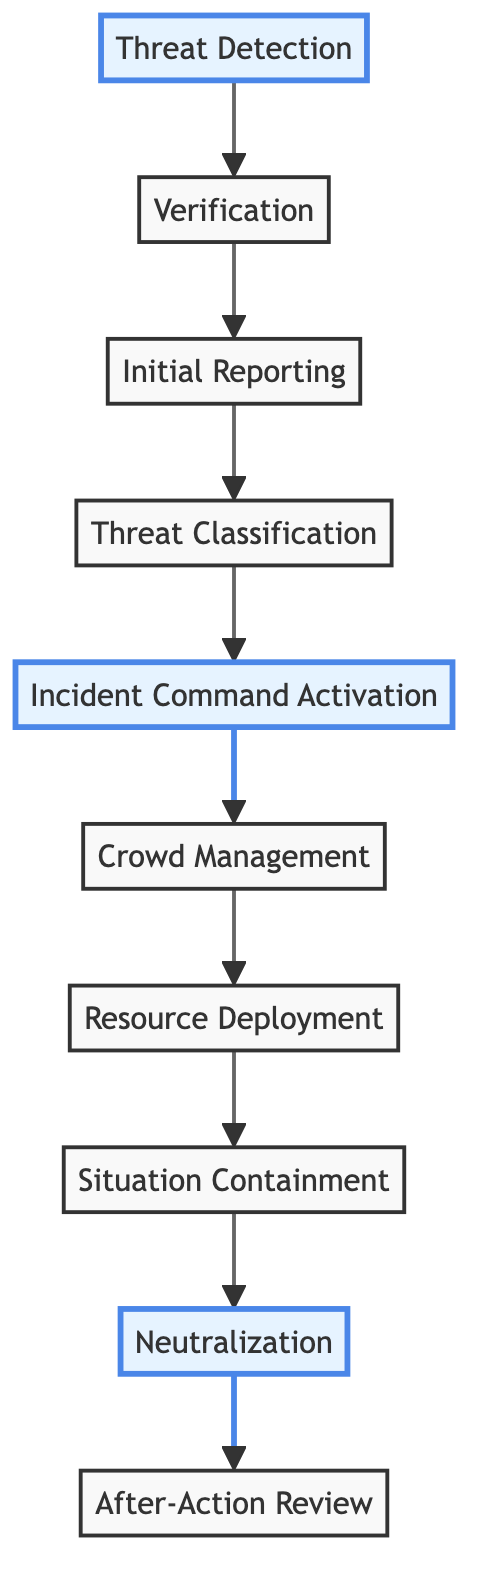What is the first step in the incident response workflow? The first step shown in the diagram is "Threat Detection," indicating it is the starting point of the workflow.
Answer: Threat Detection How many steps are involved in the incident response workflow? By counting the steps listed in the diagram, there are ten distinct steps in the workflow.
Answer: 10 What is the last step of the incident response workflow? The final step illustrated in the diagram is "After-Action Review," where evaluation and learning occur post-incident.
Answer: After-Action Review Which two steps directly precede "Neutralization"? The steps that come directly before "Neutralization" are "Situation Containment" and "Resource Deployment," indicating that situational control and resources are gathered before addressing the threat.
Answer: Situation Containment, Resource Deployment What type of threat classification can occur in step 4? Step 4 mentions the classification as either low, medium, or high, based on risk assessment criteria, denoting the seriousness of the threat.
Answer: Low, Medium, High What is required to move from "Threat Detection" to "Verification"? To progress from "Threat Detection" to "Verification," an initial alert must be received, which triggers the verification of the threat's credibility and severity.
Answer: Initial alert Which step is highlighted as the activation point in the workflow? The step highlighted as significant and activation point is "Incident Command Activation," emphasizing its importance in the coordination of the incident response.
Answer: Incident Command Activation What major actions are taken in step 6? In "Crowd Management," the major actions include implementing crowd control measures such as evacuation routes, barricades, and public communication strategies to ensure safety.
Answer: Crowd control measures What distinguishes "Neutralization" from "Situation Containment"? "Neutralization" is the action taken to eliminate the threat, while "Situation Containment" focuses on isolating the threat to prevent its escalation—indicating different stages of response.
Answer: Action taken vs. isolation of threat Why is "After-Action Review" essential in the incident response workflow? "After-Action Review" is critical for summarizing the incident, deriving lessons learned, and updating future response protocols, ensuring improved preparedness for similar events.
Answer: Continuous improvement 